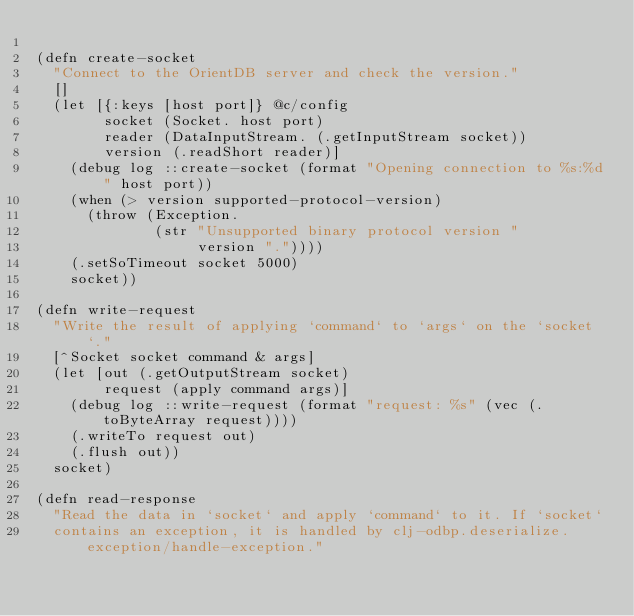Convert code to text. <code><loc_0><loc_0><loc_500><loc_500><_Clojure_>
(defn create-socket
  "Connect to the OrientDB server and check the version."
  []
  (let [{:keys [host port]} @c/config
        socket (Socket. host port)
        reader (DataInputStream. (.getInputStream socket))
        version (.readShort reader)]
    (debug log ::create-socket (format "Opening connection to %s:%d" host port))
    (when (> version supported-protocol-version)
      (throw (Exception.
              (str "Unsupported binary protocol version "
                   version "."))))
    (.setSoTimeout socket 5000)
    socket))

(defn write-request
  "Write the result of applying `command` to `args` on the `socket`."
  [^Socket socket command & args]
  (let [out (.getOutputStream socket)
        request (apply command args)]
    (debug log ::write-request (format "request: %s" (vec (.toByteArray request))))
    (.writeTo request out)
    (.flush out))
  socket)

(defn read-response
  "Read the data in `socket` and apply `command` to it. If `socket`
  contains an exception, it is handled by clj-odbp.deserialize.exception/handle-exception."</code> 